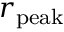<formula> <loc_0><loc_0><loc_500><loc_500>r _ { p e a k }</formula> 